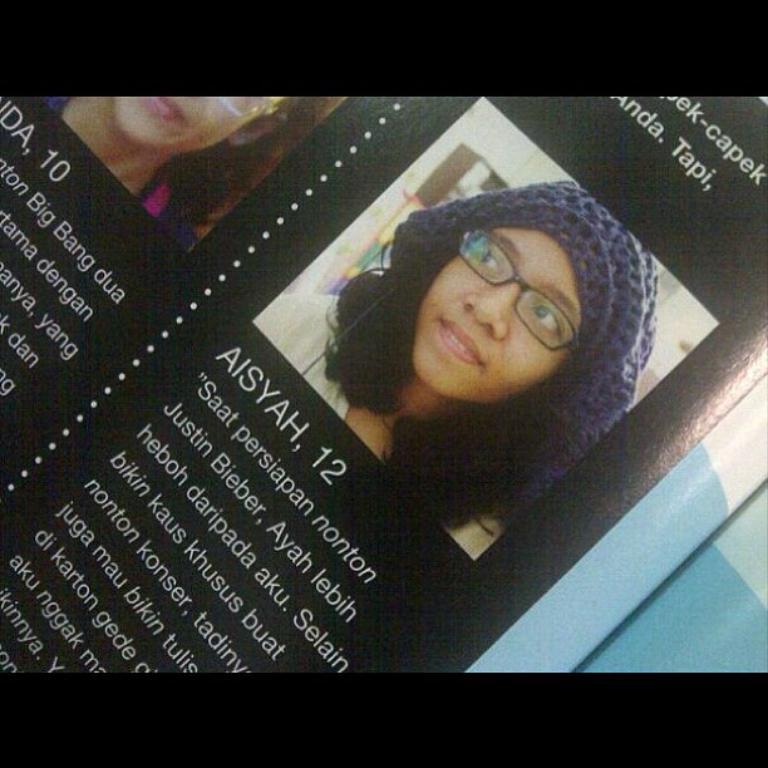How would you summarize this image in a sentence or two? Here, we can see a black color paper, on that there are some pictures of the girls and there is text printed on it. 